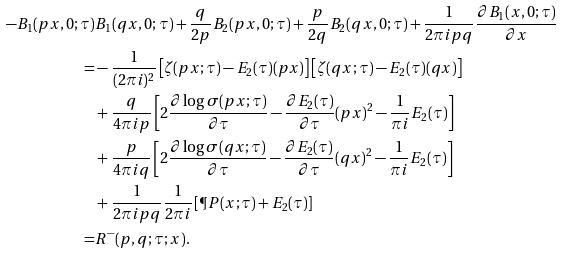<formula> <loc_0><loc_0><loc_500><loc_500>- B _ { 1 } ( p x , 0 ; \tau ) & B _ { 1 } ( q x , 0 ; \tau ) + \frac { q } { 2 p } B _ { 2 } ( p x , 0 ; \tau ) + \frac { p } { 2 q } B _ { 2 } ( q x , 0 ; \tau ) + \frac { 1 } { 2 \pi i p q } \frac { \partial B _ { 1 } ( x , 0 ; \tau ) } { \partial x } \\ = & - \frac { 1 } { ( 2 \pi i ) ^ { 2 } } \left [ \zeta ( p x ; \tau ) - E _ { 2 } ( \tau ) ( p x ) \right ] \left [ \zeta ( q x ; \tau ) - E _ { 2 } ( \tau ) ( q x ) \right ] \\ & + \frac { q } { 4 \pi i p } \left [ 2 \frac { \partial \log \sigma ( p x ; \tau ) } { \partial \tau } - \frac { \partial E _ { 2 } ( \tau ) } { \partial \tau } ( p x ) ^ { 2 } - \frac { 1 } { \pi i } E _ { 2 } ( \tau ) \right ] \\ & + \frac { p } { 4 \pi i q } \left [ 2 \frac { \partial \log \sigma ( q x ; \tau ) } { \partial \tau } - \frac { \partial E _ { 2 } ( \tau ) } { \partial \tau } ( q x ) ^ { 2 } - \frac { 1 } { \pi i } E _ { 2 } ( \tau ) \right ] \\ & + \frac { 1 } { 2 \pi i p q } \frac { 1 } { 2 \pi i } \left [ \P P ( x ; \tau ) + E _ { 2 } ( \tau ) \right ] \\ = & R ^ { - } ( p , q ; \tau ; x ) .</formula> 